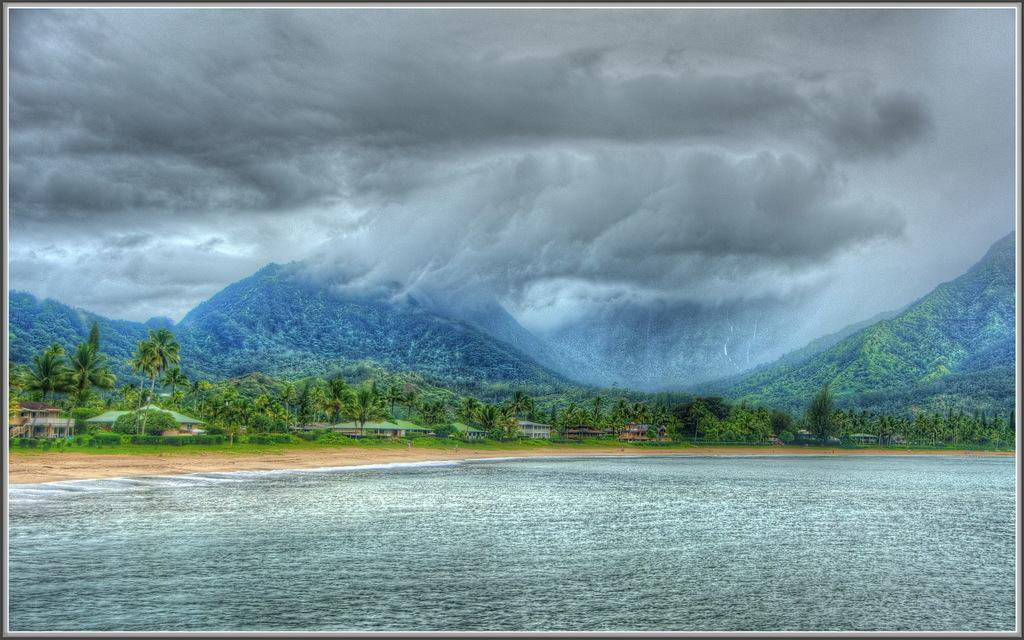Please provide a concise description of this image. This is an edited picture. In this image there are mountains, trees and buildings. At the top there is sky and there are clouds. At the bottom there is water, mud and grass. 